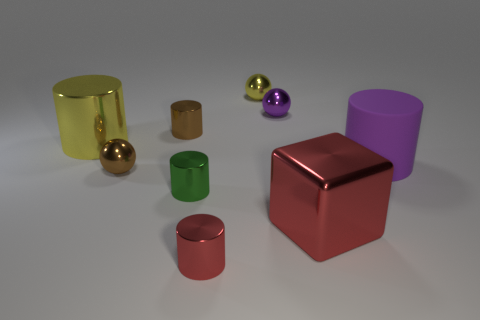Subtract all yellow metallic spheres. How many spheres are left? 2 Subtract all spheres. How many objects are left? 6 Subtract all green cylinders. How many cylinders are left? 4 Subtract 0 gray balls. How many objects are left? 9 Subtract 2 cylinders. How many cylinders are left? 3 Subtract all brown cylinders. Subtract all blue blocks. How many cylinders are left? 4 Subtract all purple balls. Subtract all big yellow metal things. How many objects are left? 7 Add 1 purple metallic things. How many purple metallic things are left? 2 Add 3 yellow balls. How many yellow balls exist? 4 